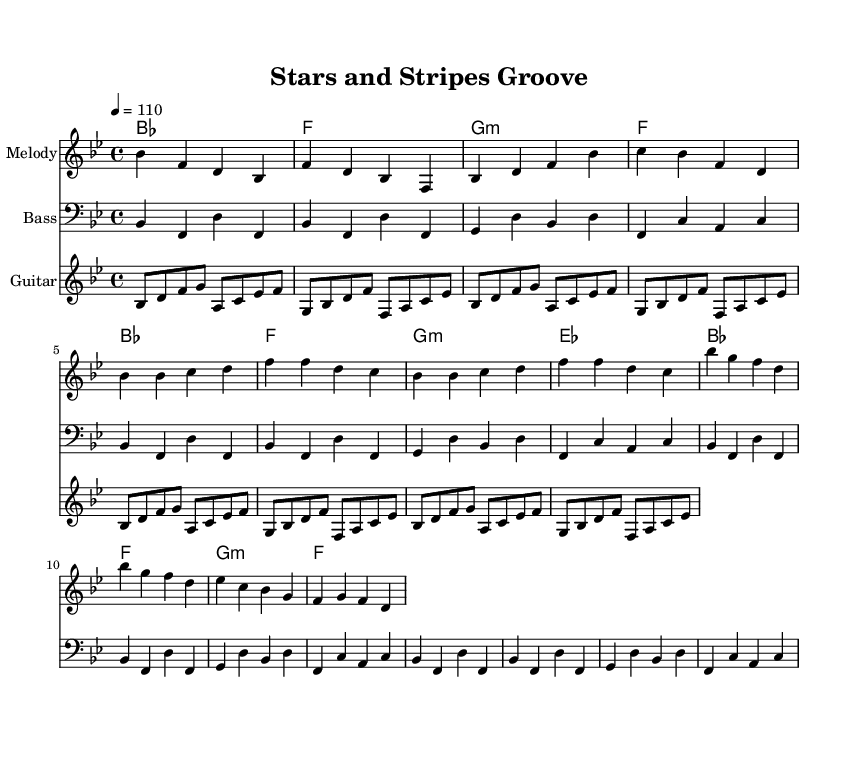What is the key signature of this music? The key signature in the music indicates that it is in B-flat major, which has two flats (B-flat and E-flat). This can be identified by looking at the signature on the staff at the beginning of the piece.
Answer: B-flat major What is the time signature of the piece? The time signature is found at the beginning near the key signature, and it shows that the piece is in 4/4 time, meaning there are four beats in each measure.
Answer: 4/4 What is the tempo marking in this music? The tempo marking is indicated above the staff and shows that the speed of the music is set to quarter note equals 110 beats per minute. This can be found in the tempo instruction at the beginning of the score.
Answer: 110 How many measures are in the intro section? To determine the number of measures in the intro section, we can count the measures from the starting point to the first section of the verse. There are four distinct measures in the intro.
Answer: 4 What type of chords are used in the chorus? By analyzing the harmony part during the chorus section, we can identify that the chords primarily consist of major and minor chords, specifically B-flat major, F major, and G minor.
Answer: Major and minor What is the structure of the song? The structure can be analyzed by identifying the sections in the music. It begins with an intro, followed by verses and then a chorus. This repetitive format is typical in funk music, emphasizing groove and rhythm.
Answer: Intro, Verse, Chorus What role does the guitar play in this piece? The guitar plays a rhythmic riff that complements the bass and melody, adding to the overall groove typical of funk. This can be seen in the repeating guitar riff throughout the score.
Answer: Rhythmic riff 